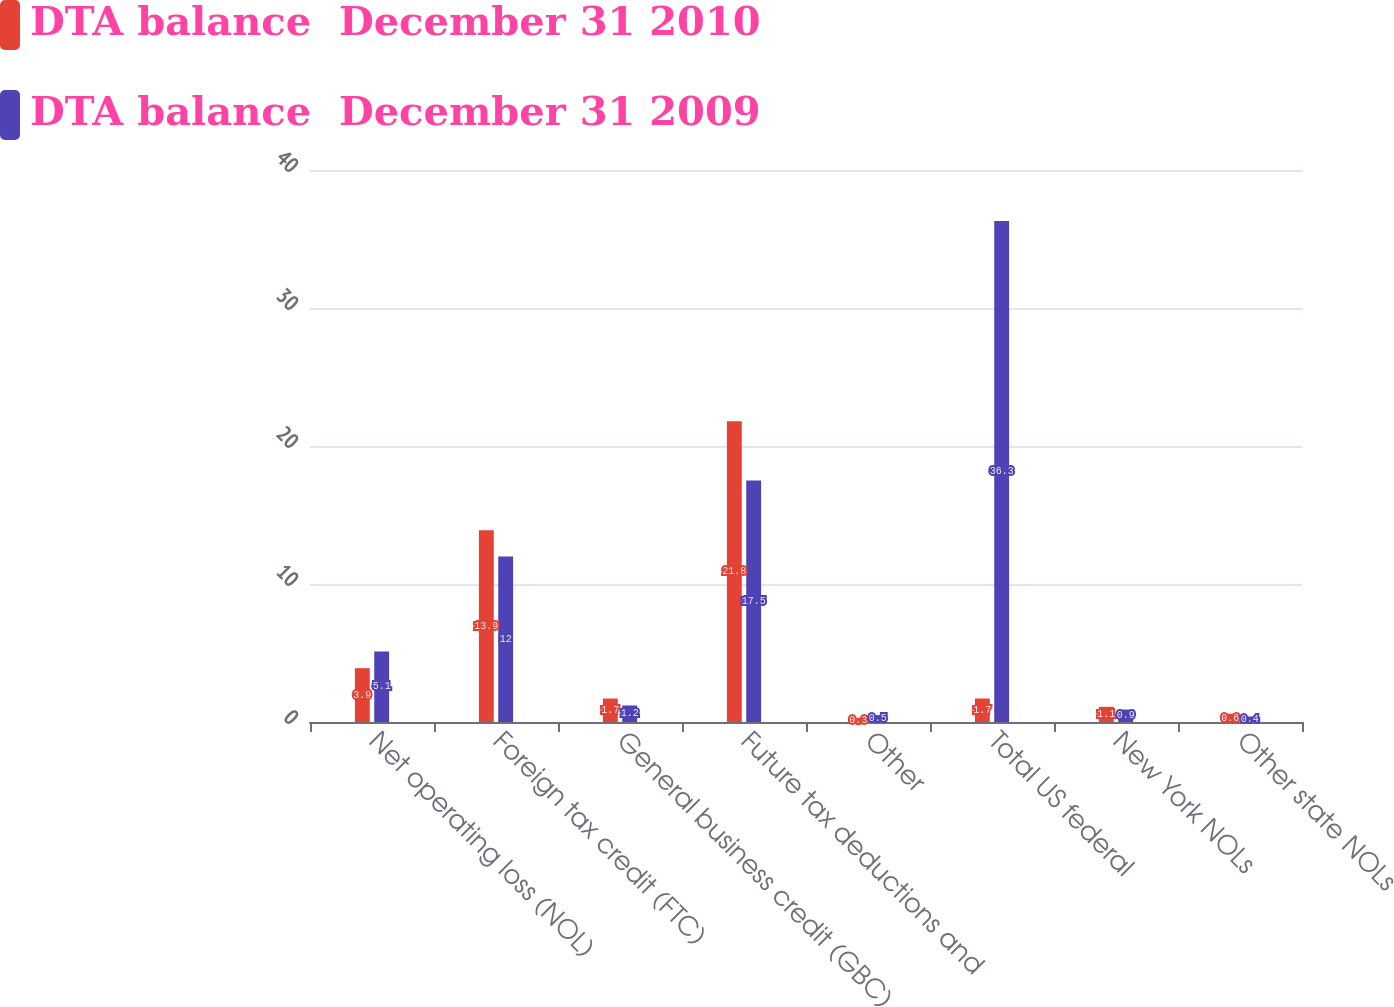<chart> <loc_0><loc_0><loc_500><loc_500><stacked_bar_chart><ecel><fcel>Net operating loss (NOL)<fcel>Foreign tax credit (FTC)<fcel>General business credit (GBC)<fcel>Future tax deductions and<fcel>Other<fcel>Total US federal<fcel>New York NOLs<fcel>Other state NOLs<nl><fcel>DTA balance  December 31 2010<fcel>3.9<fcel>13.9<fcel>1.7<fcel>21.8<fcel>0.3<fcel>1.7<fcel>1.1<fcel>0.6<nl><fcel>DTA balance  December 31 2009<fcel>5.1<fcel>12<fcel>1.2<fcel>17.5<fcel>0.5<fcel>36.3<fcel>0.9<fcel>0.4<nl></chart> 